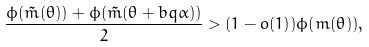<formula> <loc_0><loc_0><loc_500><loc_500>\frac { \phi ( \tilde { m } ( \theta ) ) + \phi ( \tilde { m } ( \theta + b q \alpha ) ) } { 2 } > ( 1 - o ( 1 ) ) \phi ( m ( \theta ) ) ,</formula> 